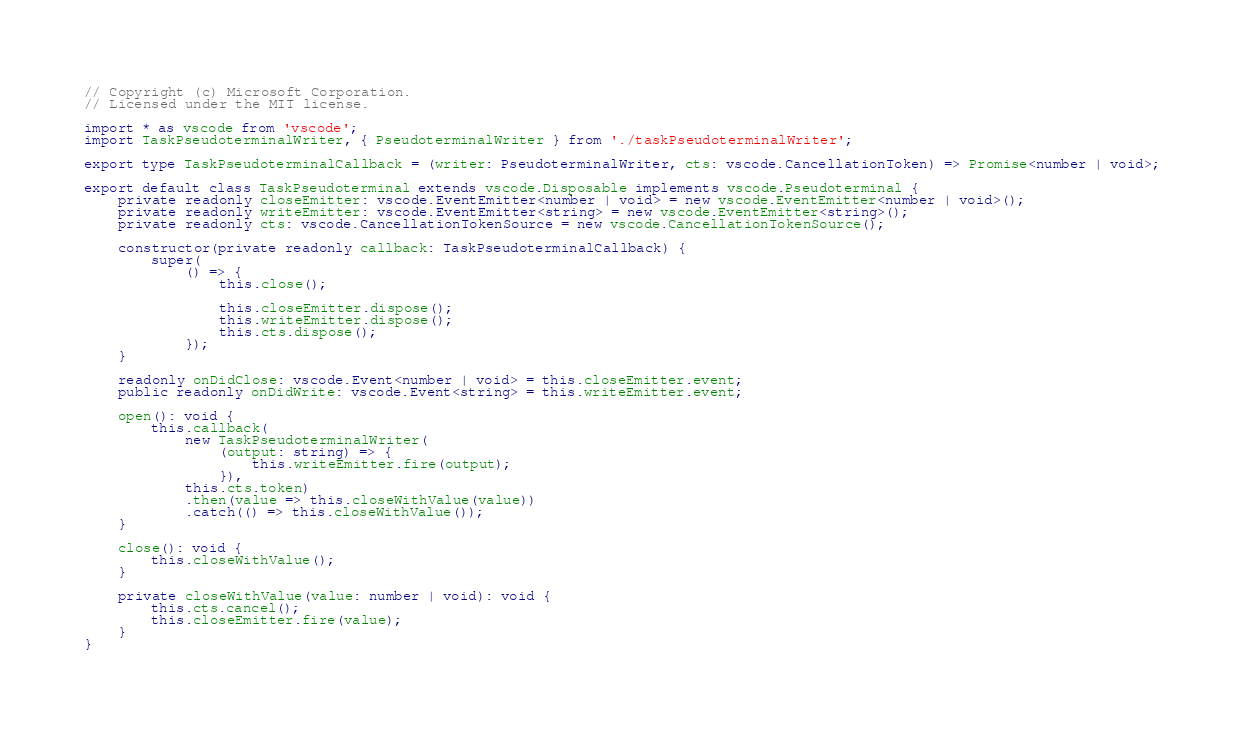<code> <loc_0><loc_0><loc_500><loc_500><_TypeScript_>// Copyright (c) Microsoft Corporation.
// Licensed under the MIT license.

import * as vscode from 'vscode';
import TaskPseudoterminalWriter, { PseudoterminalWriter } from './taskPseudoterminalWriter';

export type TaskPseudoterminalCallback = (writer: PseudoterminalWriter, cts: vscode.CancellationToken) => Promise<number | void>;

export default class TaskPseudoterminal extends vscode.Disposable implements vscode.Pseudoterminal {
    private readonly closeEmitter: vscode.EventEmitter<number | void> = new vscode.EventEmitter<number | void>();
    private readonly writeEmitter: vscode.EventEmitter<string> = new vscode.EventEmitter<string>();
    private readonly cts: vscode.CancellationTokenSource = new vscode.CancellationTokenSource();

    constructor(private readonly callback: TaskPseudoterminalCallback) {
        super(
            () => {
                this.close();

                this.closeEmitter.dispose();
                this.writeEmitter.dispose();
                this.cts.dispose();
            });
    }

    readonly onDidClose: vscode.Event<number | void> = this.closeEmitter.event;
    public readonly onDidWrite: vscode.Event<string> = this.writeEmitter.event;

    open(): void {
        this.callback(
            new TaskPseudoterminalWriter(
                (output: string) => {
                    this.writeEmitter.fire(output);
                }),
            this.cts.token)
            .then(value => this.closeWithValue(value))
            .catch(() => this.closeWithValue());
    }

    close(): void {
        this.closeWithValue();
    }

    private closeWithValue(value: number | void): void {
        this.cts.cancel();
        this.closeEmitter.fire(value);
    }
}</code> 